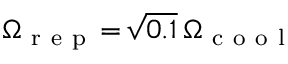Convert formula to latex. <formula><loc_0><loc_0><loc_500><loc_500>\Omega _ { r e p } \, = \, \sqrt { 0 . 1 } \, \Omega _ { c o o l }</formula> 